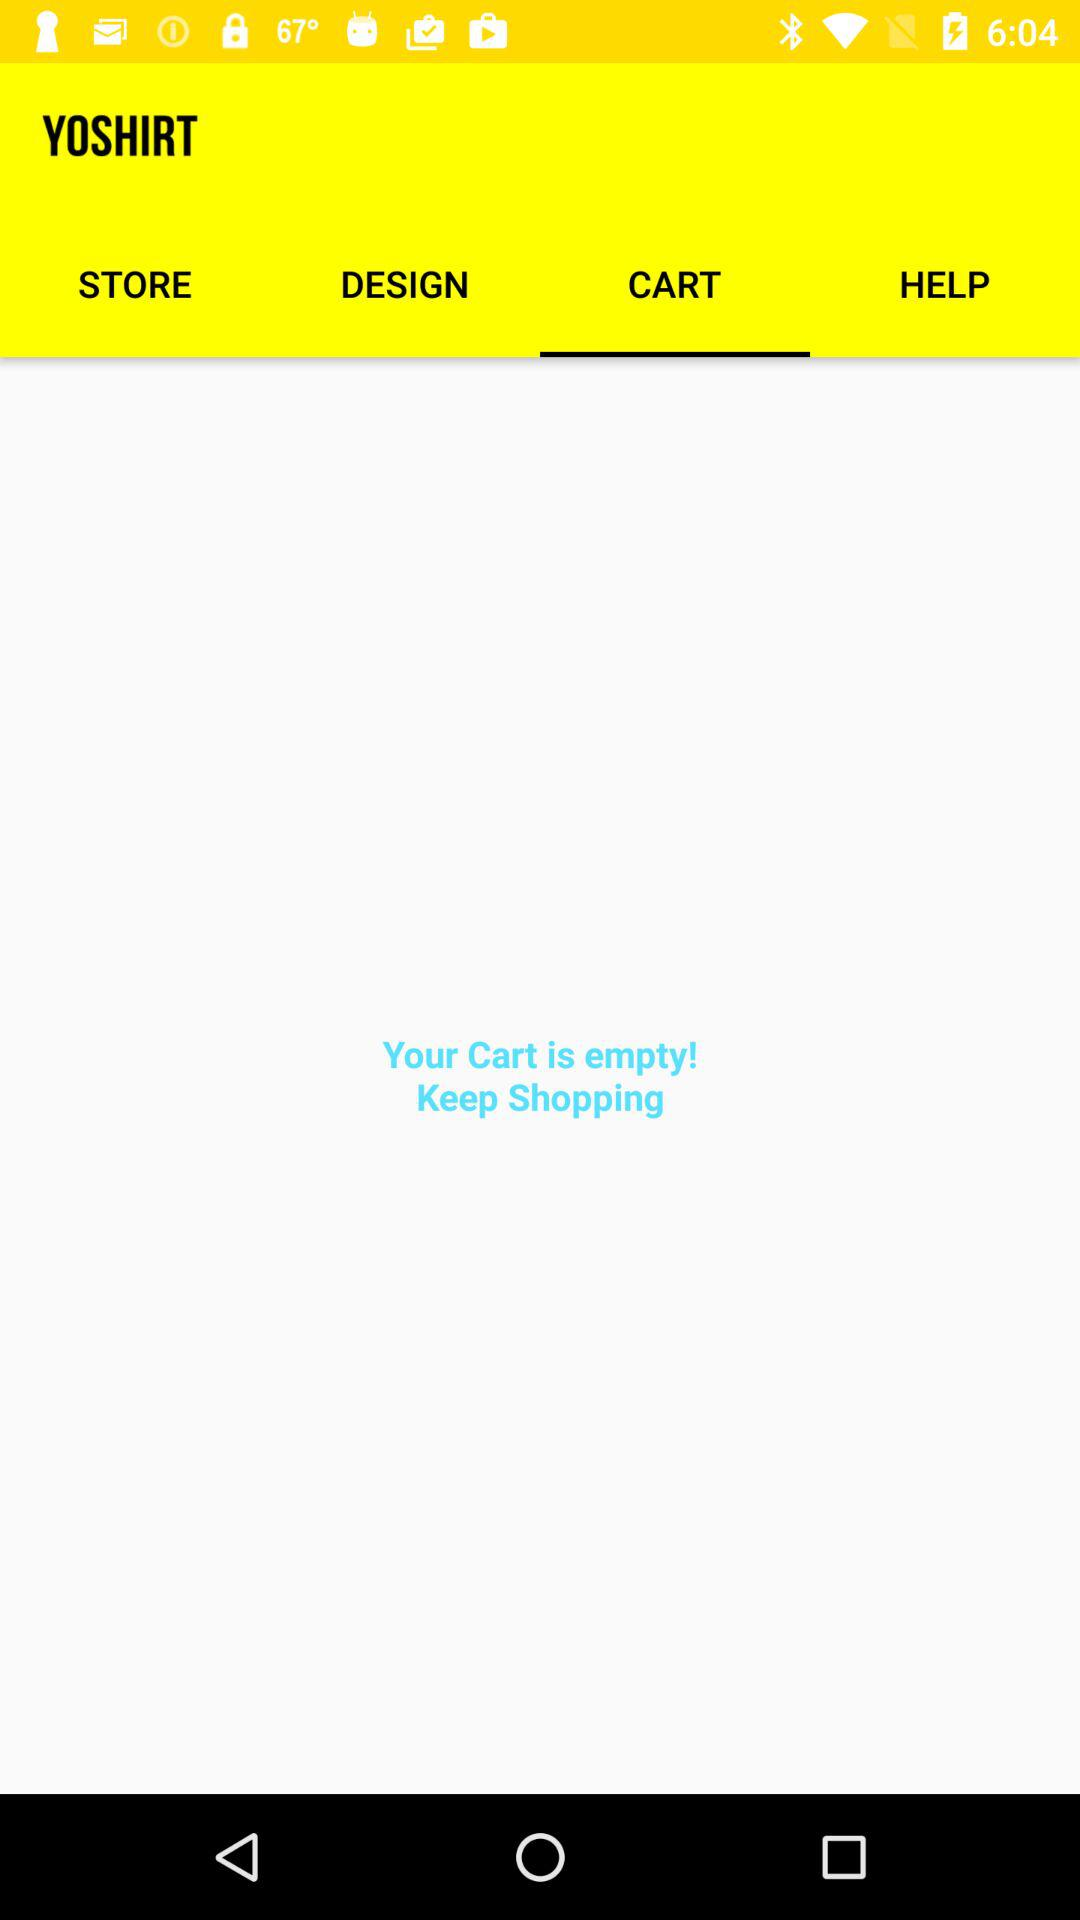What is the name of the application? The application name is "YOSHIRT". 